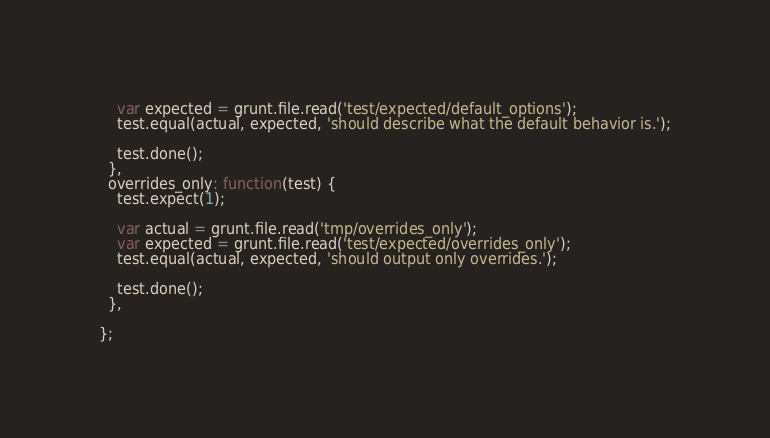Convert code to text. <code><loc_0><loc_0><loc_500><loc_500><_JavaScript_>    var expected = grunt.file.read('test/expected/default_options');
    test.equal(actual, expected, 'should describe what the default behavior is.');

    test.done();
  },
  overrides_only: function(test) {
    test.expect(1);

    var actual = grunt.file.read('tmp/overrides_only');
    var expected = grunt.file.read('test/expected/overrides_only');
    test.equal(actual, expected, 'should output only overrides.');

    test.done();
  },

};
</code> 